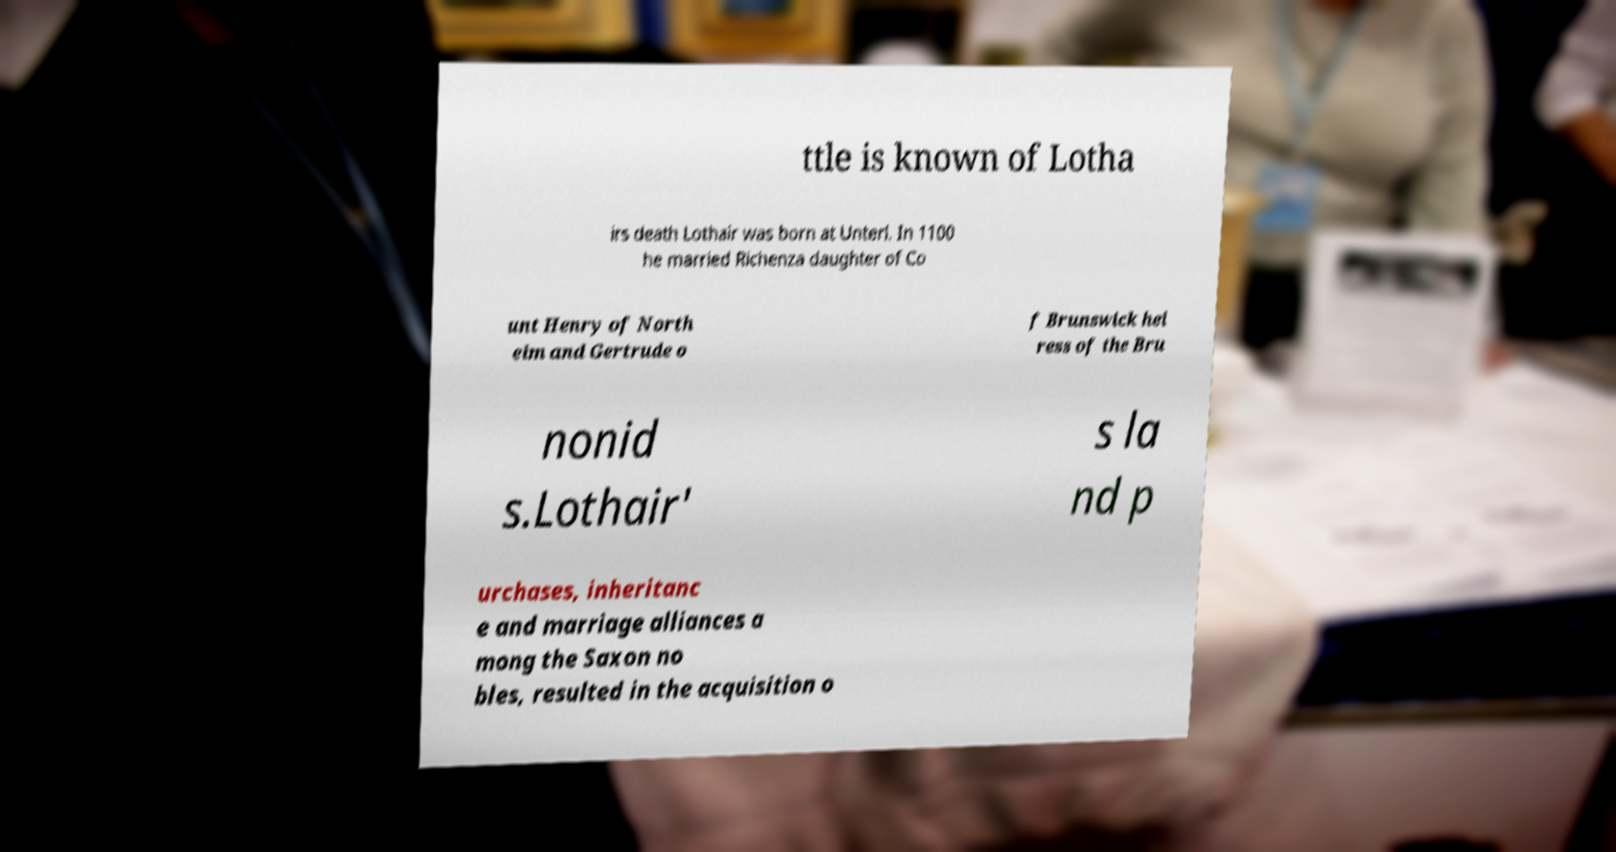Could you assist in decoding the text presented in this image and type it out clearly? ttle is known of Lotha irs death Lothair was born at Unterl. In 1100 he married Richenza daughter of Co unt Henry of North eim and Gertrude o f Brunswick hei ress of the Bru nonid s.Lothair' s la nd p urchases, inheritanc e and marriage alliances a mong the Saxon no bles, resulted in the acquisition o 